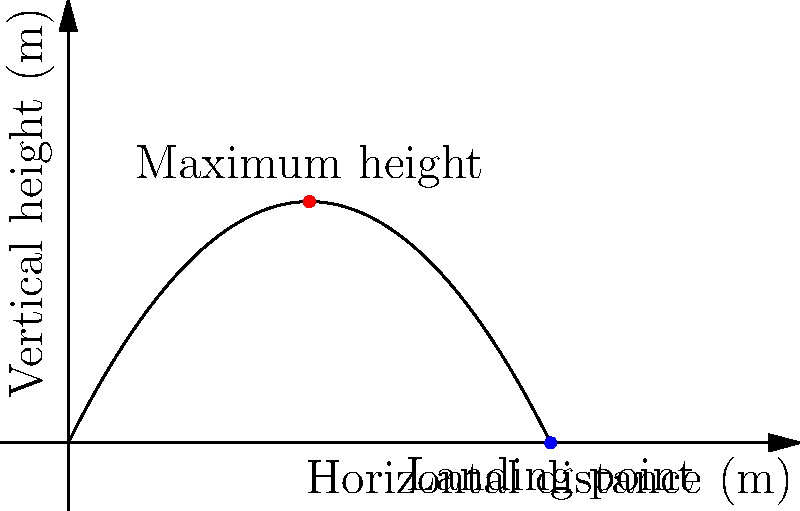The graph shows the trajectory of a ball thrown in the air. At what horizontal distance does the ball reach its maximum height? To find the horizontal distance at which the ball reaches its maximum height, we need to analyze the graph:

1. The trajectory of the ball is represented by a parabola.
2. The highest point of a parabola is at its vertex.
3. The vertex of this parabola is the point where the ball reaches its maximum height.
4. Looking at the graph, we can see that the vertex is located directly above the midpoint of the horizontal distance.
5. The ball lands at 10 meters horizontally (where the curve intersects the x-axis).
6. The midpoint of 0 to 10 meters is 5 meters.

Therefore, the ball reaches its maximum height when it has traveled half of its total horizontal distance, which is 5 meters.
Answer: 5 meters 